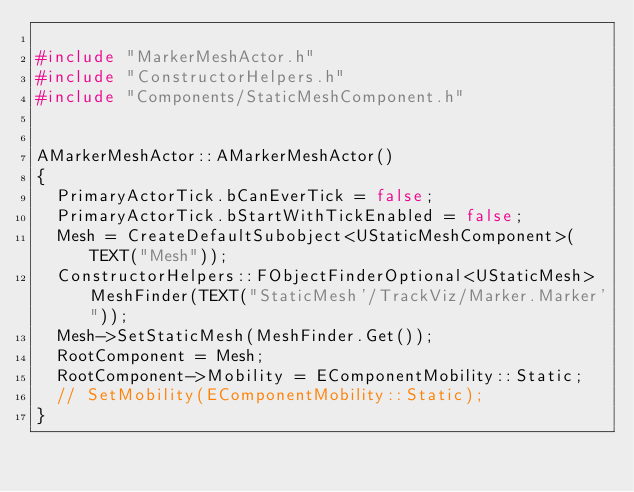<code> <loc_0><loc_0><loc_500><loc_500><_C++_>
#include "MarkerMeshActor.h"
#include "ConstructorHelpers.h"
#include "Components/StaticMeshComponent.h"


AMarkerMeshActor::AMarkerMeshActor()
{
	PrimaryActorTick.bCanEverTick = false;
	PrimaryActorTick.bStartWithTickEnabled = false;
	Mesh = CreateDefaultSubobject<UStaticMeshComponent>(TEXT("Mesh"));
	ConstructorHelpers::FObjectFinderOptional<UStaticMesh> MeshFinder(TEXT("StaticMesh'/TrackViz/Marker.Marker'"));
	Mesh->SetStaticMesh(MeshFinder.Get());
	RootComponent = Mesh;
	RootComponent->Mobility = EComponentMobility::Static;
	// SetMobility(EComponentMobility::Static);
}
</code> 